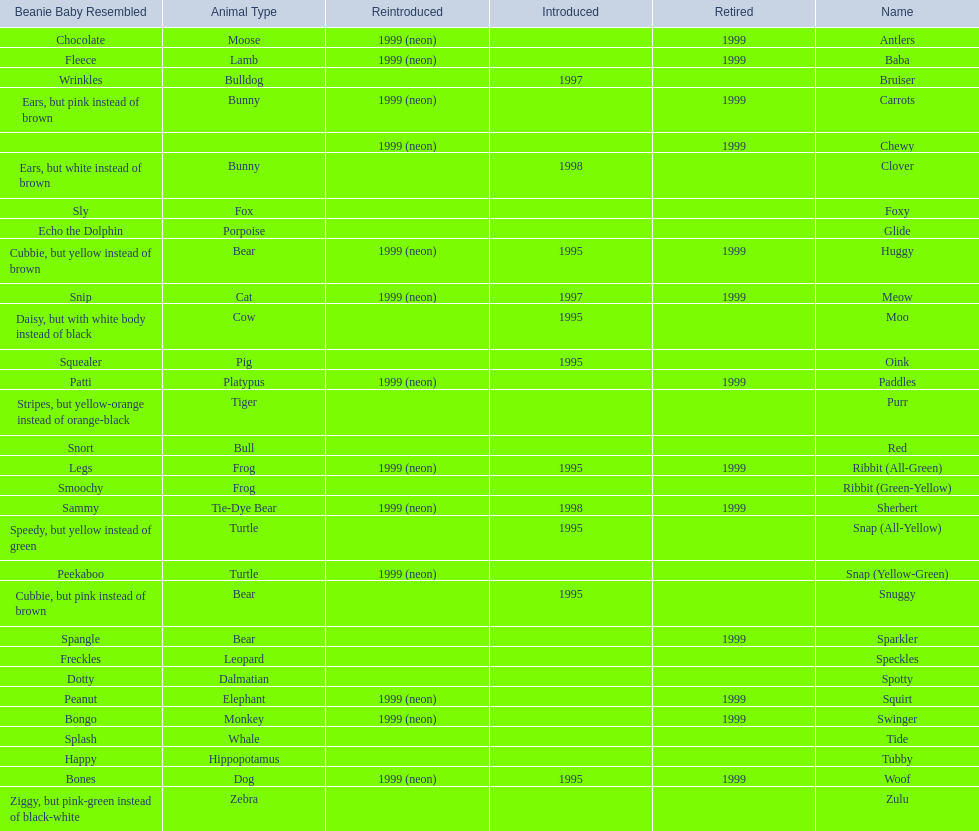Which of the listed pillow pals lack information in at least 3 categories? Chewy, Foxy, Glide, Purr, Red, Ribbit (Green-Yellow), Speckles, Spotty, Tide, Tubby, Zulu. Of those, which one lacks information in the animal type category? Chewy. 